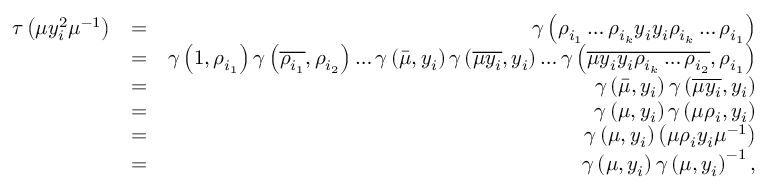<formula> <loc_0><loc_0><loc_500><loc_500>\begin{array} { r l r } { \tau \left ( \mu y _ { i } ^ { 2 } \mu ^ { - 1 } \right ) } & { = } & { \gamma \left ( \rho _ { i _ { 1 } } \dots \rho _ { i _ { k } } y _ { i } y _ { i } \rho _ { i _ { k } } \dots \rho _ { i _ { 1 } } \right ) } \\ & { = } & { \gamma \left ( 1 , \rho _ { i _ { 1 } } \right ) \gamma \left ( \overline { { \rho _ { i _ { 1 } } } } , \rho _ { i _ { 2 } } \right ) \dots \gamma \left ( \bar { \mu } , y _ { i } \right ) \gamma \left ( \overline { { \mu y _ { i } } } , y _ { i } \right ) \dots \gamma \left ( \overline { { \mu y _ { i } y _ { i } \rho _ { i _ { k } } \dots \rho _ { i _ { 2 } } } } , \rho _ { i _ { 1 } } \right ) } \\ & { = } & { \gamma \left ( \bar { \mu } , y _ { i } \right ) \gamma \left ( \overline { { \mu y _ { i } } } , y _ { i } \right ) } \\ & { = } & { \gamma \left ( \mu , y _ { i } \right ) \gamma \left ( \mu \rho _ { i } , y _ { i } \right ) } \\ & { = } & { \gamma \left ( \mu , y _ { i } \right ) \left ( \mu \rho _ { i } y _ { i } \mu ^ { - 1 } \right ) } \\ & { = } & { \gamma \left ( \mu , y _ { i } \right ) \gamma \left ( \mu , y _ { i } \right ) ^ { - 1 } , } \end{array}</formula> 